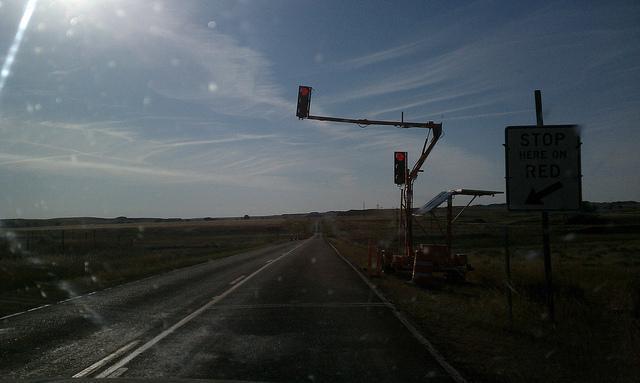How many vehicles are visible?
Give a very brief answer. 0. How many street lights are there?
Give a very brief answer. 2. 